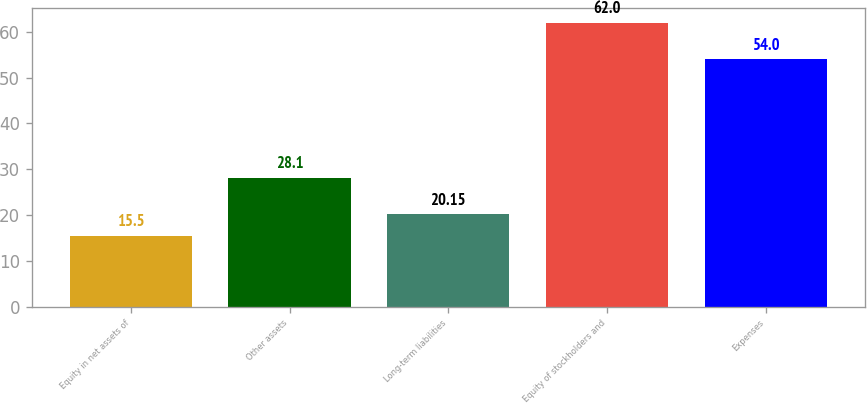Convert chart to OTSL. <chart><loc_0><loc_0><loc_500><loc_500><bar_chart><fcel>Equity in net assets of<fcel>Other assets<fcel>Long-term liabilities<fcel>Equity of stockholders and<fcel>Expenses<nl><fcel>15.5<fcel>28.1<fcel>20.15<fcel>62<fcel>54<nl></chart> 